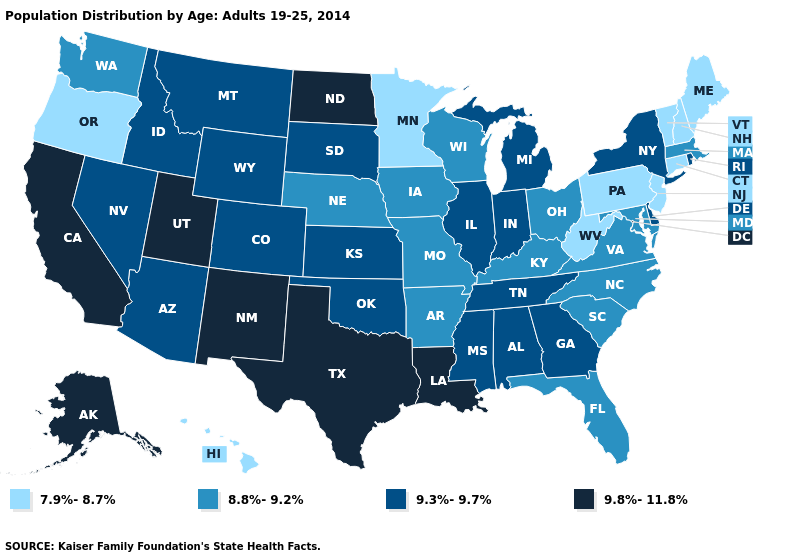Which states have the lowest value in the West?
Write a very short answer. Hawaii, Oregon. Does Nevada have a lower value than Mississippi?
Be succinct. No. What is the value of Oregon?
Write a very short answer. 7.9%-8.7%. What is the value of South Carolina?
Be succinct. 8.8%-9.2%. Does Minnesota have the highest value in the USA?
Give a very brief answer. No. Does Maryland have a lower value than Arkansas?
Write a very short answer. No. What is the value of Massachusetts?
Give a very brief answer. 8.8%-9.2%. What is the value of Kansas?
Write a very short answer. 9.3%-9.7%. Does New Jersey have the lowest value in the USA?
Quick response, please. Yes. Which states hav the highest value in the West?
Quick response, please. Alaska, California, New Mexico, Utah. Does Minnesota have the lowest value in the MidWest?
Be succinct. Yes. Does Maryland have a lower value than Colorado?
Answer briefly. Yes. Does the first symbol in the legend represent the smallest category?
Quick response, please. Yes. 